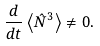Convert formula to latex. <formula><loc_0><loc_0><loc_500><loc_500>\frac { d } { d t } \left < \hat { N } ^ { 3 } \right > \neq 0 .</formula> 